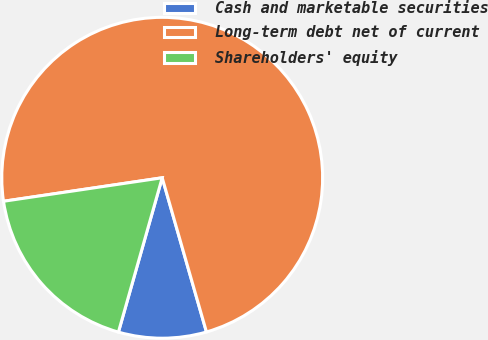Convert chart to OTSL. <chart><loc_0><loc_0><loc_500><loc_500><pie_chart><fcel>Cash and marketable securities<fcel>Long-term debt net of current<fcel>Shareholders' equity<nl><fcel>8.85%<fcel>72.89%<fcel>18.26%<nl></chart> 